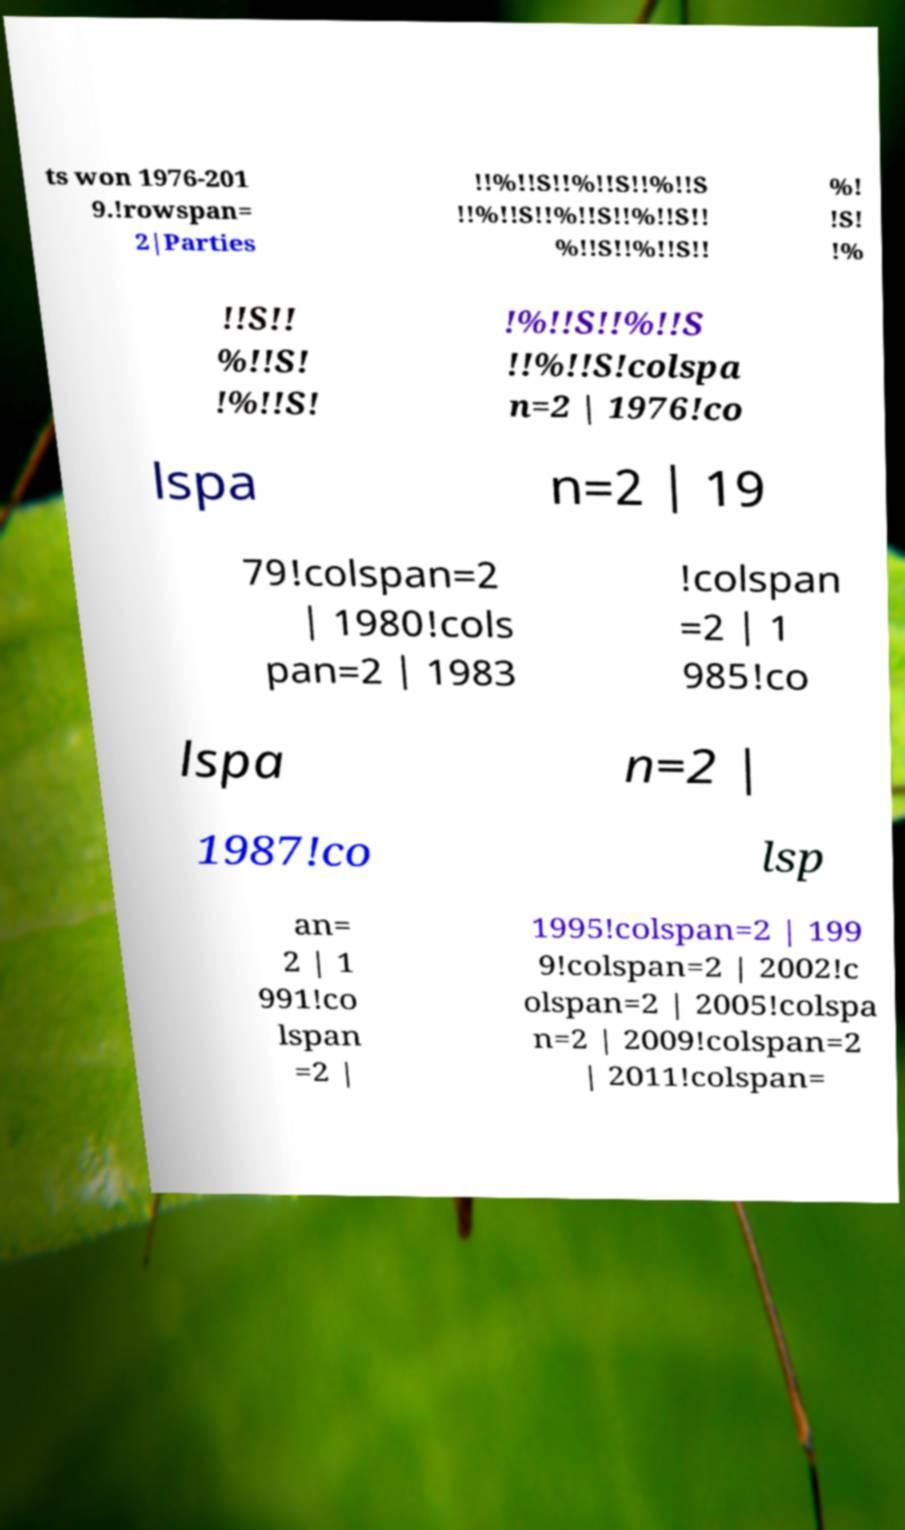Could you assist in decoding the text presented in this image and type it out clearly? ts won 1976-201 9.!rowspan= 2|Parties !!%!!S!!%!!S!!%!!S !!%!!S!!%!!S!!%!!S!! %!!S!!%!!S!! %! !S! !% !!S!! %!!S! !%!!S! !%!!S!!%!!S !!%!!S!colspa n=2 | 1976!co lspa n=2 | 19 79!colspan=2 | 1980!cols pan=2 | 1983 !colspan =2 | 1 985!co lspa n=2 | 1987!co lsp an= 2 | 1 991!co lspan =2 | 1995!colspan=2 | 199 9!colspan=2 | 2002!c olspan=2 | 2005!colspa n=2 | 2009!colspan=2 | 2011!colspan= 